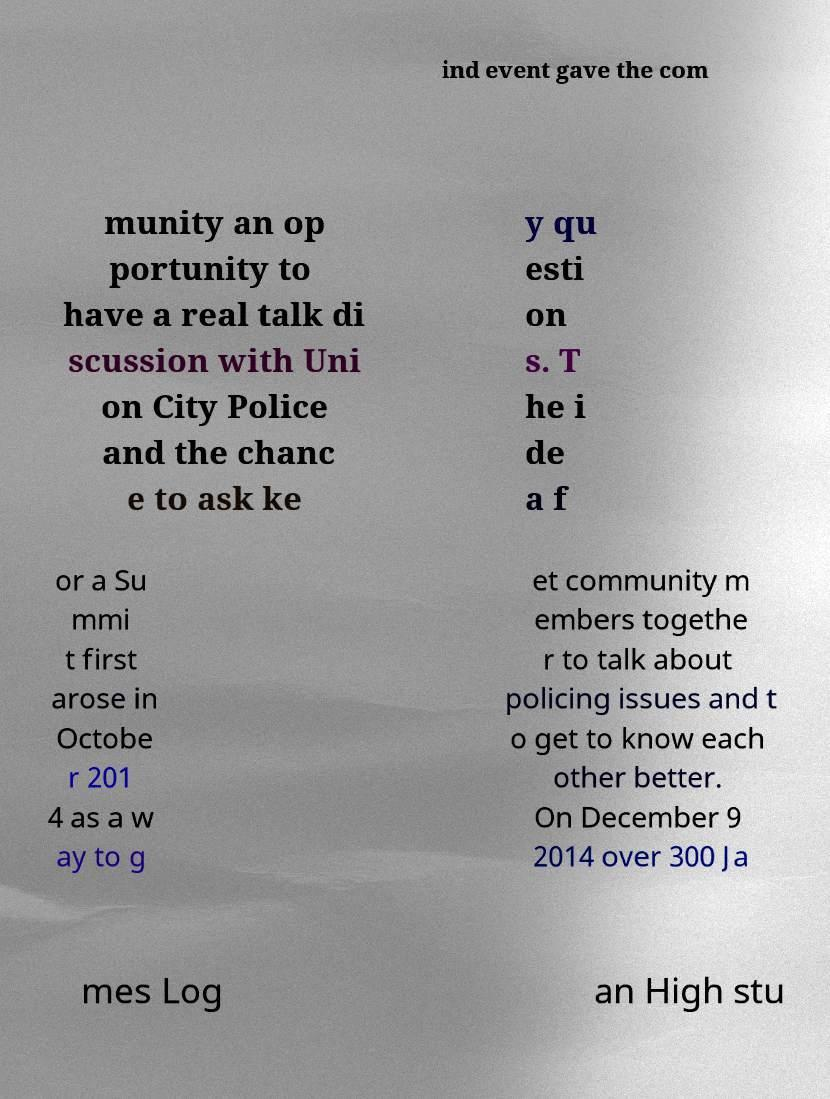Could you extract and type out the text from this image? ind event gave the com munity an op portunity to have a real talk di scussion with Uni on City Police and the chanc e to ask ke y qu esti on s. T he i de a f or a Su mmi t first arose in Octobe r 201 4 as a w ay to g et community m embers togethe r to talk about policing issues and t o get to know each other better. On December 9 2014 over 300 Ja mes Log an High stu 